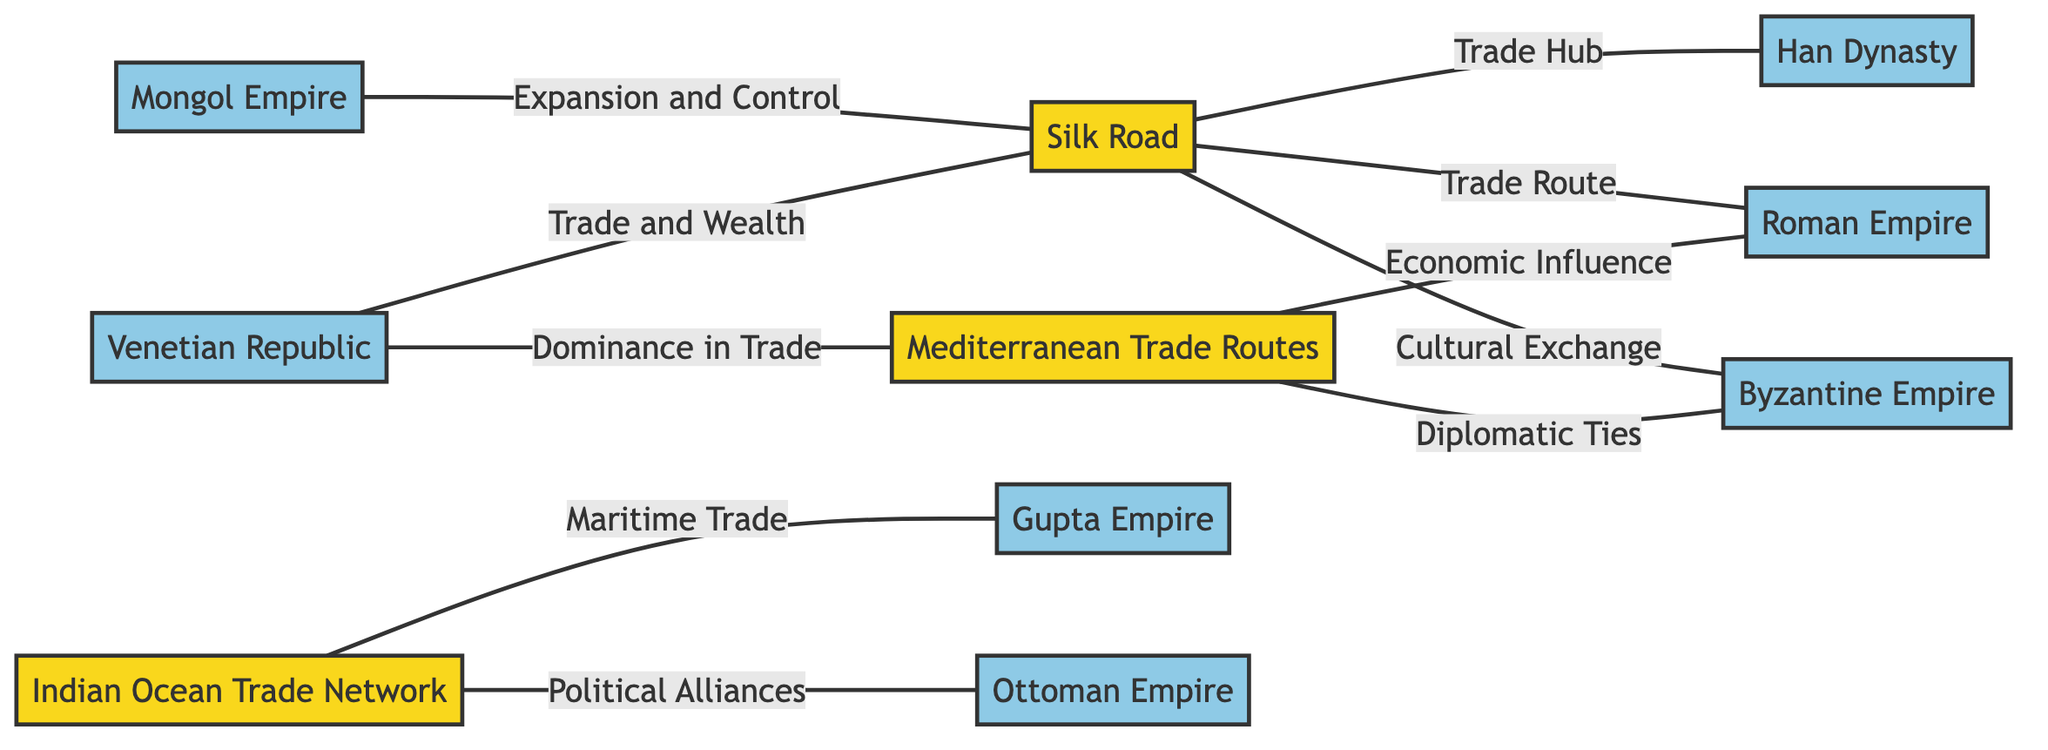What is the total number of trade routes shown in the diagram? The diagram lists three main trade routes: Silk Road, Mediterranean Trade Routes, and Indian Ocean Trade Network. These are all represented as nodes, so counting them gives us the total number.
Answer: 3 Which empire is connected to the Silk Road primarily through a trade hub? The Silk Road is connected to the Han Dynasty, labeled as a "Trade Hub," meaning this is the primary relationship indicated between the two nodes.
Answer: Han Dynasty What type of exchange exists between the Silk Road and the Byzantine Empire? The edge connecting Silk Road and Byzantine Empire is labeled "Cultural Exchange," indicating the nature of this relationship directly on the diagram.
Answer: Cultural Exchange Which trade route has a connection to the Gupta Empire? The Indian Ocean Trade Network has a connection labeled "Maritime Trade" to the Gupta Empire, which identifies this specific trade relationship.
Answer: Indian Ocean Trade Network How many empires are associated with the Mediterranean Trade Routes? The diagram shows two connections for Mediterranean Trade Routes: one to the Roman Empire for "Economic Influence" and another one to the Byzantine Empire for "Diplomatic Ties." Therefore, counting these relationships, we identify the total number of associated empires.
Answer: 2 Which empire is represented as dominating trade routes both in the Silk Road and the Mediterranean Trade Routes? The Venetian Republic is connected to both the Silk Road and Mediterranean Trade Routes, which indicates its dominance in these trade networks highlighting its importance in trade in this historical context.
Answer: Venetian Republic What relationship is depicted between the Indian Ocean Trade Network and the Ottoman Empire? The relationship is labeled as "Political Alliances," indicating specifically how the Indian Ocean Trade Network influenced political ties with the Ottoman Empire in the diagram.
Answer: Political Alliances Which empire expanded its control over the Silk Road? The diagram indicates that the Mongol Empire is the one linked to the Silk Road with the label "Expansion and Control," demonstrating how it exerted influence over this trade route.
Answer: Mongol Empire How many cultural exchanges are represented in the diagram? There is one edge titled "Cultural Exchange" connecting the Silk Road and the Byzantine Empire, thus there is a single instance of a cultural exchange indicated.
Answer: 1 